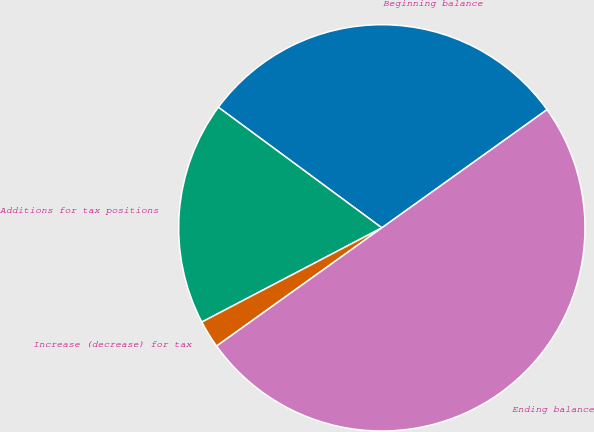Convert chart to OTSL. <chart><loc_0><loc_0><loc_500><loc_500><pie_chart><fcel>Beginning balance<fcel>Additions for tax positions<fcel>Increase (decrease) for tax<fcel>Ending balance<nl><fcel>30.0%<fcel>17.79%<fcel>2.21%<fcel>50.0%<nl></chart> 